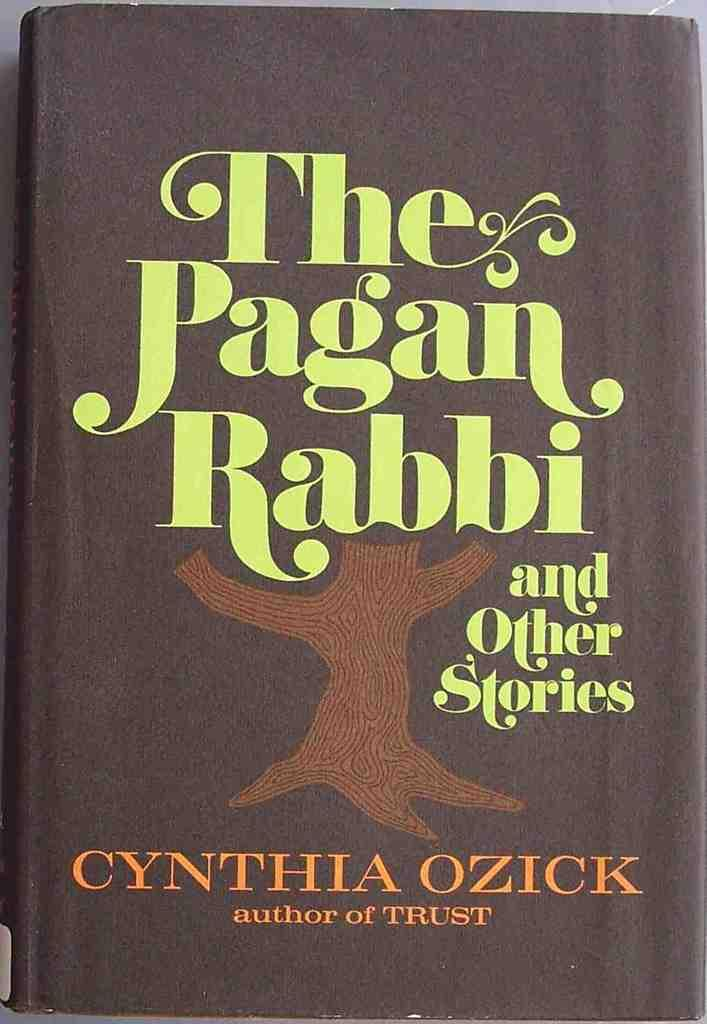Provide a one-sentence caption for the provided image. A book called "the Pagan Rabbi" is shown close up. 